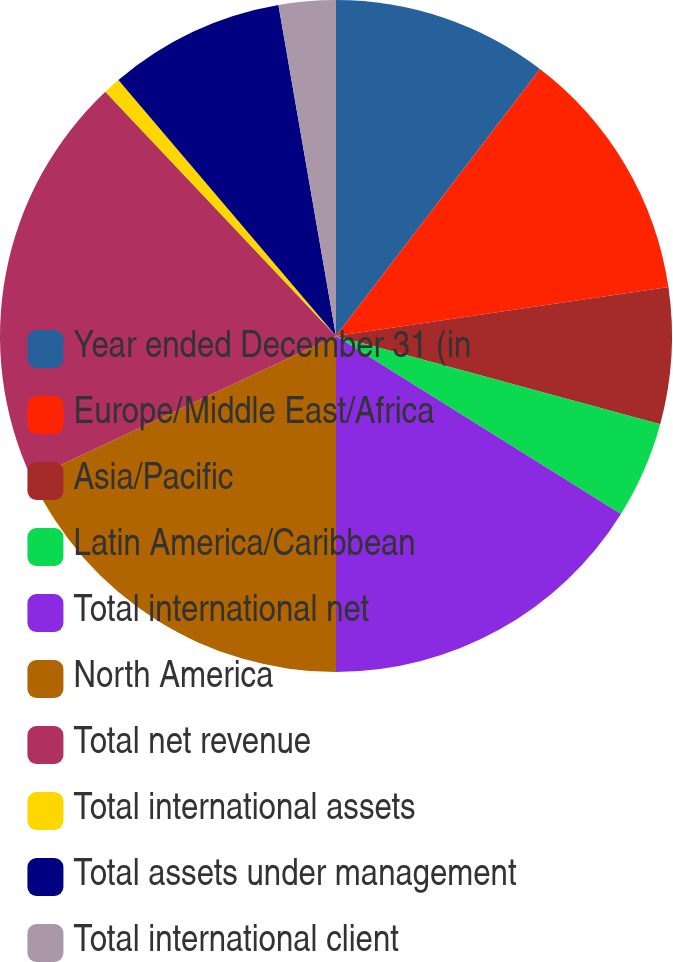Convert chart. <chart><loc_0><loc_0><loc_500><loc_500><pie_chart><fcel>Year ended December 31 (in<fcel>Europe/Middle East/Africa<fcel>Asia/Pacific<fcel>Latin America/Caribbean<fcel>Total international net<fcel>North America<fcel>Total net revenue<fcel>Total international assets<fcel>Total assets under management<fcel>Total international client<nl><fcel>10.38%<fcel>12.29%<fcel>6.56%<fcel>4.65%<fcel>16.11%<fcel>18.02%<fcel>19.93%<fcel>0.83%<fcel>8.47%<fcel>2.74%<nl></chart> 